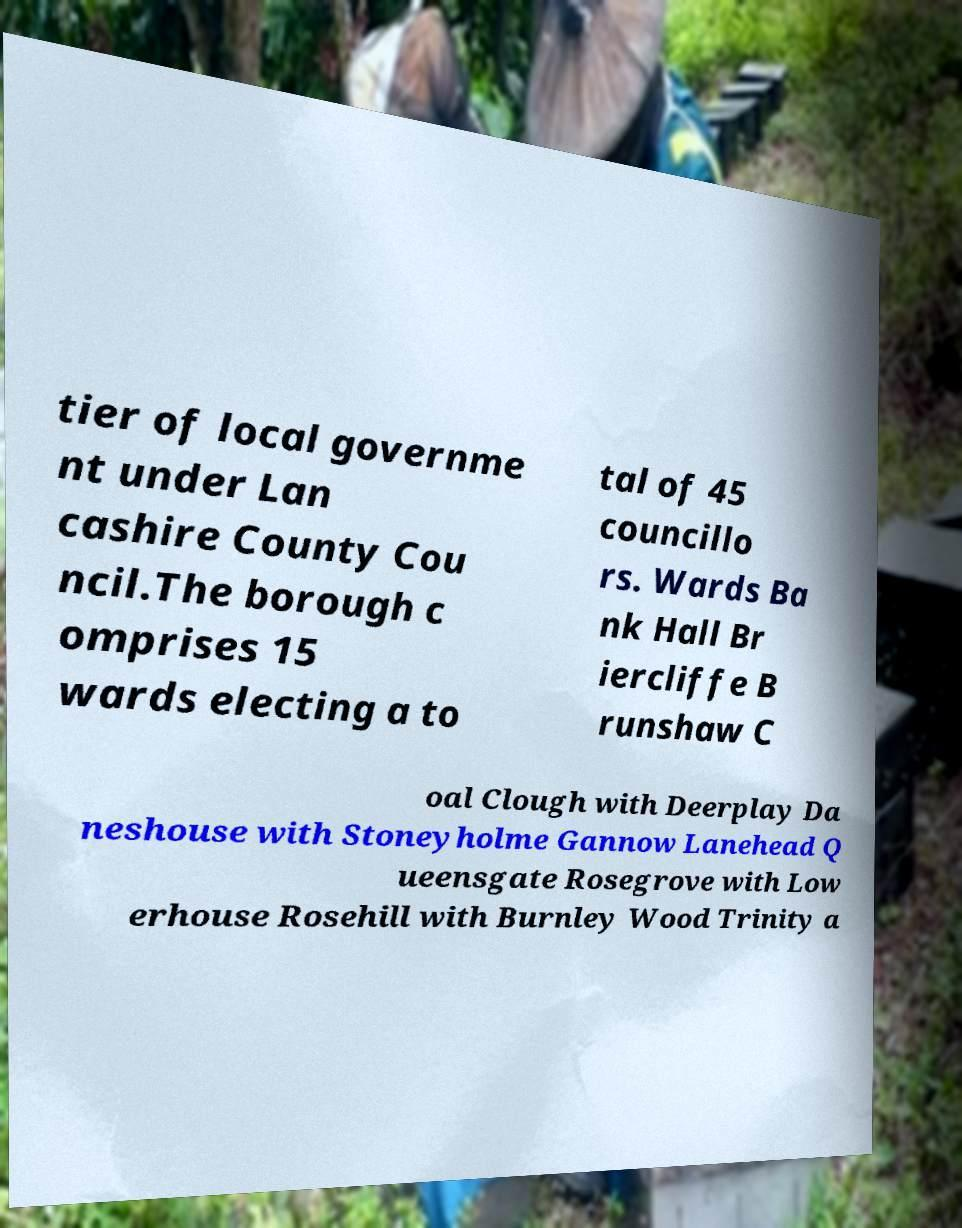There's text embedded in this image that I need extracted. Can you transcribe it verbatim? tier of local governme nt under Lan cashire County Cou ncil.The borough c omprises 15 wards electing a to tal of 45 councillo rs. Wards Ba nk Hall Br iercliffe B runshaw C oal Clough with Deerplay Da neshouse with Stoneyholme Gannow Lanehead Q ueensgate Rosegrove with Low erhouse Rosehill with Burnley Wood Trinity a 